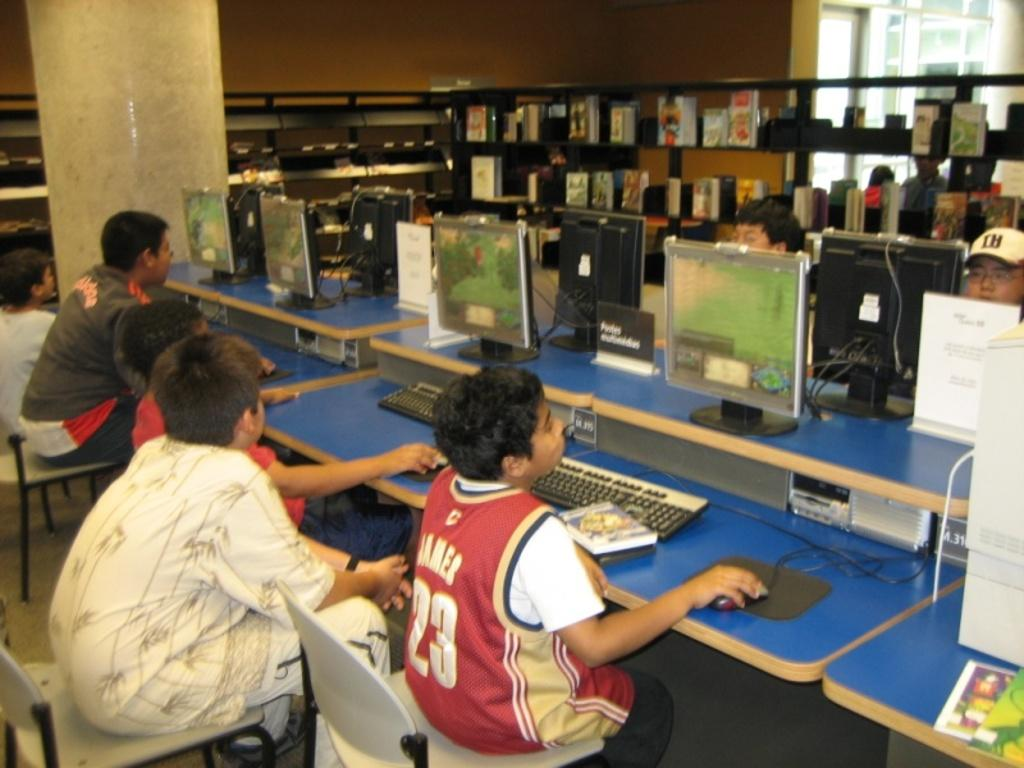What is stored on the racks in the image? The racks are filled with books. What electronic devices are on the table? There are monitors, keyboards, and mice on the table. What are the people sitting on in the image? The people are sitting on chairs. What architectural feature can be seen in the image? There is a pillar in the image. What subjects are the sisters teaching in the image? There is no indication of sisters or teaching in the image. How does the rest of the room look in the image? The provided facts do not give information about the rest of the room, so it cannot be described. 